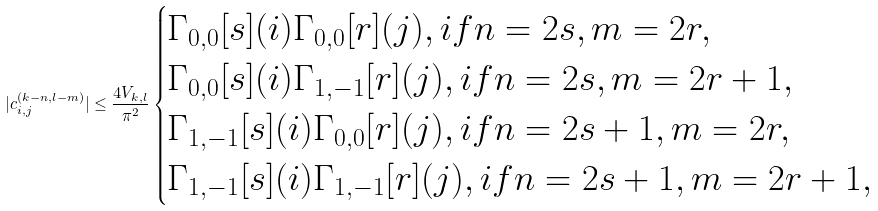<formula> <loc_0><loc_0><loc_500><loc_500>| c _ { i , j } ^ { ( k - n , l - m ) } | \leq \frac { 4 V _ { k , l } } { \pi ^ { 2 } } \begin{cases} \Gamma _ { 0 , 0 } [ s ] ( i ) \Gamma _ { 0 , 0 } [ r ] ( j ) , i f n = 2 s , m = 2 r , \\ \Gamma _ { 0 , 0 } [ s ] ( i ) \Gamma _ { 1 , - 1 } [ r ] ( j ) , i f n = 2 s , m = 2 r + 1 , \\ \Gamma _ { 1 , - 1 } [ s ] ( i ) \Gamma _ { 0 , 0 } [ r ] ( j ) , i f n = 2 s + 1 , m = 2 r , \\ \Gamma _ { 1 , - 1 } [ s ] ( i ) \Gamma _ { 1 , - 1 } [ r ] ( j ) , i f n = 2 s + 1 , m = 2 r + 1 , \end{cases}</formula> 